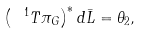<formula> <loc_0><loc_0><loc_500><loc_500>\left ( \ ^ { 1 } T \pi _ { G } \right ) ^ { \ast } d \bar { L } = \theta _ { 2 } ,</formula> 